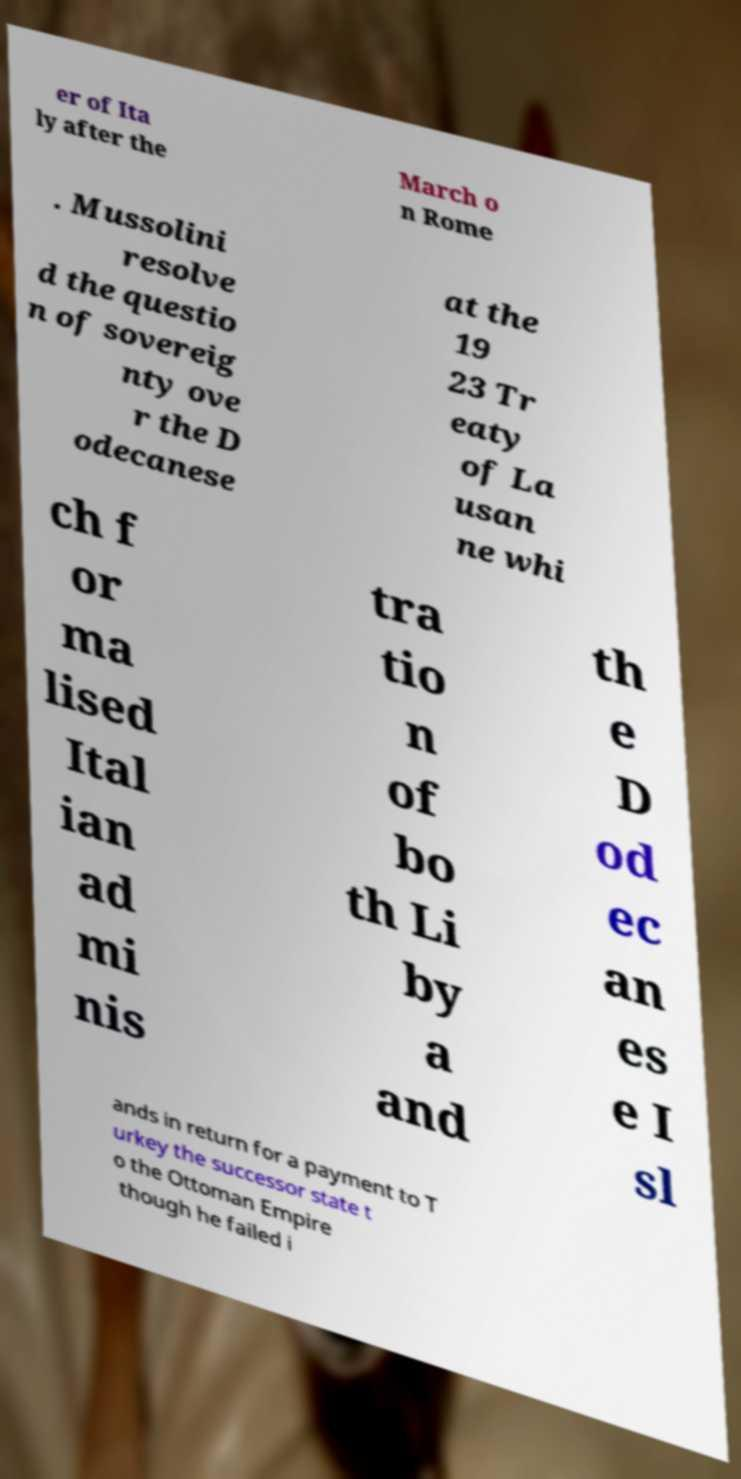Could you assist in decoding the text presented in this image and type it out clearly? er of Ita ly after the March o n Rome . Mussolini resolve d the questio n of sovereig nty ove r the D odecanese at the 19 23 Tr eaty of La usan ne whi ch f or ma lised Ital ian ad mi nis tra tio n of bo th Li by a and th e D od ec an es e I sl ands in return for a payment to T urkey the successor state t o the Ottoman Empire though he failed i 